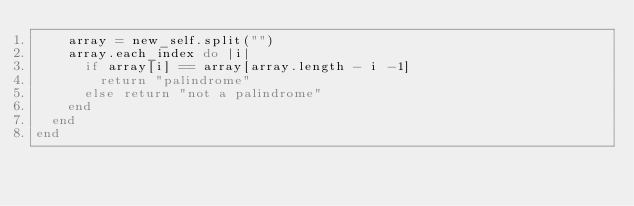Convert code to text. <code><loc_0><loc_0><loc_500><loc_500><_Ruby_>    array = new_self.split("")
    array.each_index do |i|
      if array[i] == array[array.length - i -1]
        return "palindrome"
      else return "not a palindrome"
    end
  end
end
</code> 